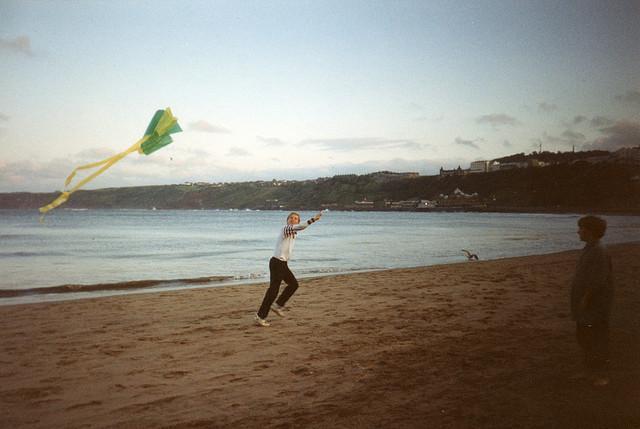How many people are there?
Give a very brief answer. 2. How many cars are in the picture?
Give a very brief answer. 0. 